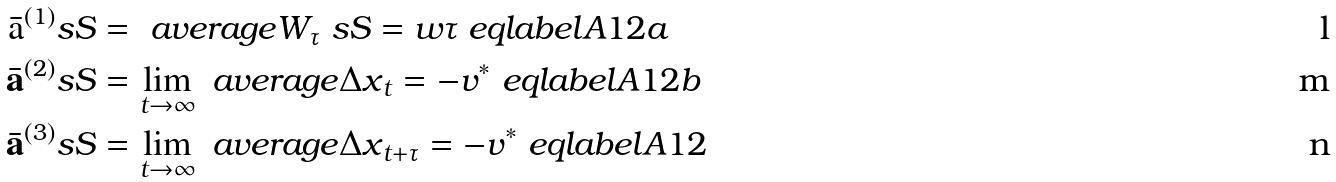Convert formula to latex. <formula><loc_0><loc_0><loc_500><loc_500>\bar { \mathrm a } ^ { ( 1 ) } _ { \ } s S & = \ a v e r a g e { W _ { \tau } } _ { \ } s S = w \tau \ e q l a b e l { A 1 2 a } \\ \bar { \mathbf a } ^ { ( 2 ) } _ { \ } s S & = \lim _ { t \to \infty } \ a v e r a g e { { \Delta x } _ { t } } = - v ^ { * } \ e q l a b e l { A 1 2 b } \\ \bar { \mathbf a } ^ { ( 3 ) } _ { \ } s S & = \lim _ { t \to \infty } \ a v e r a g e { { \Delta x } _ { t + \tau } } = - v ^ { * } \ e q l a b e l { A 1 2 }</formula> 